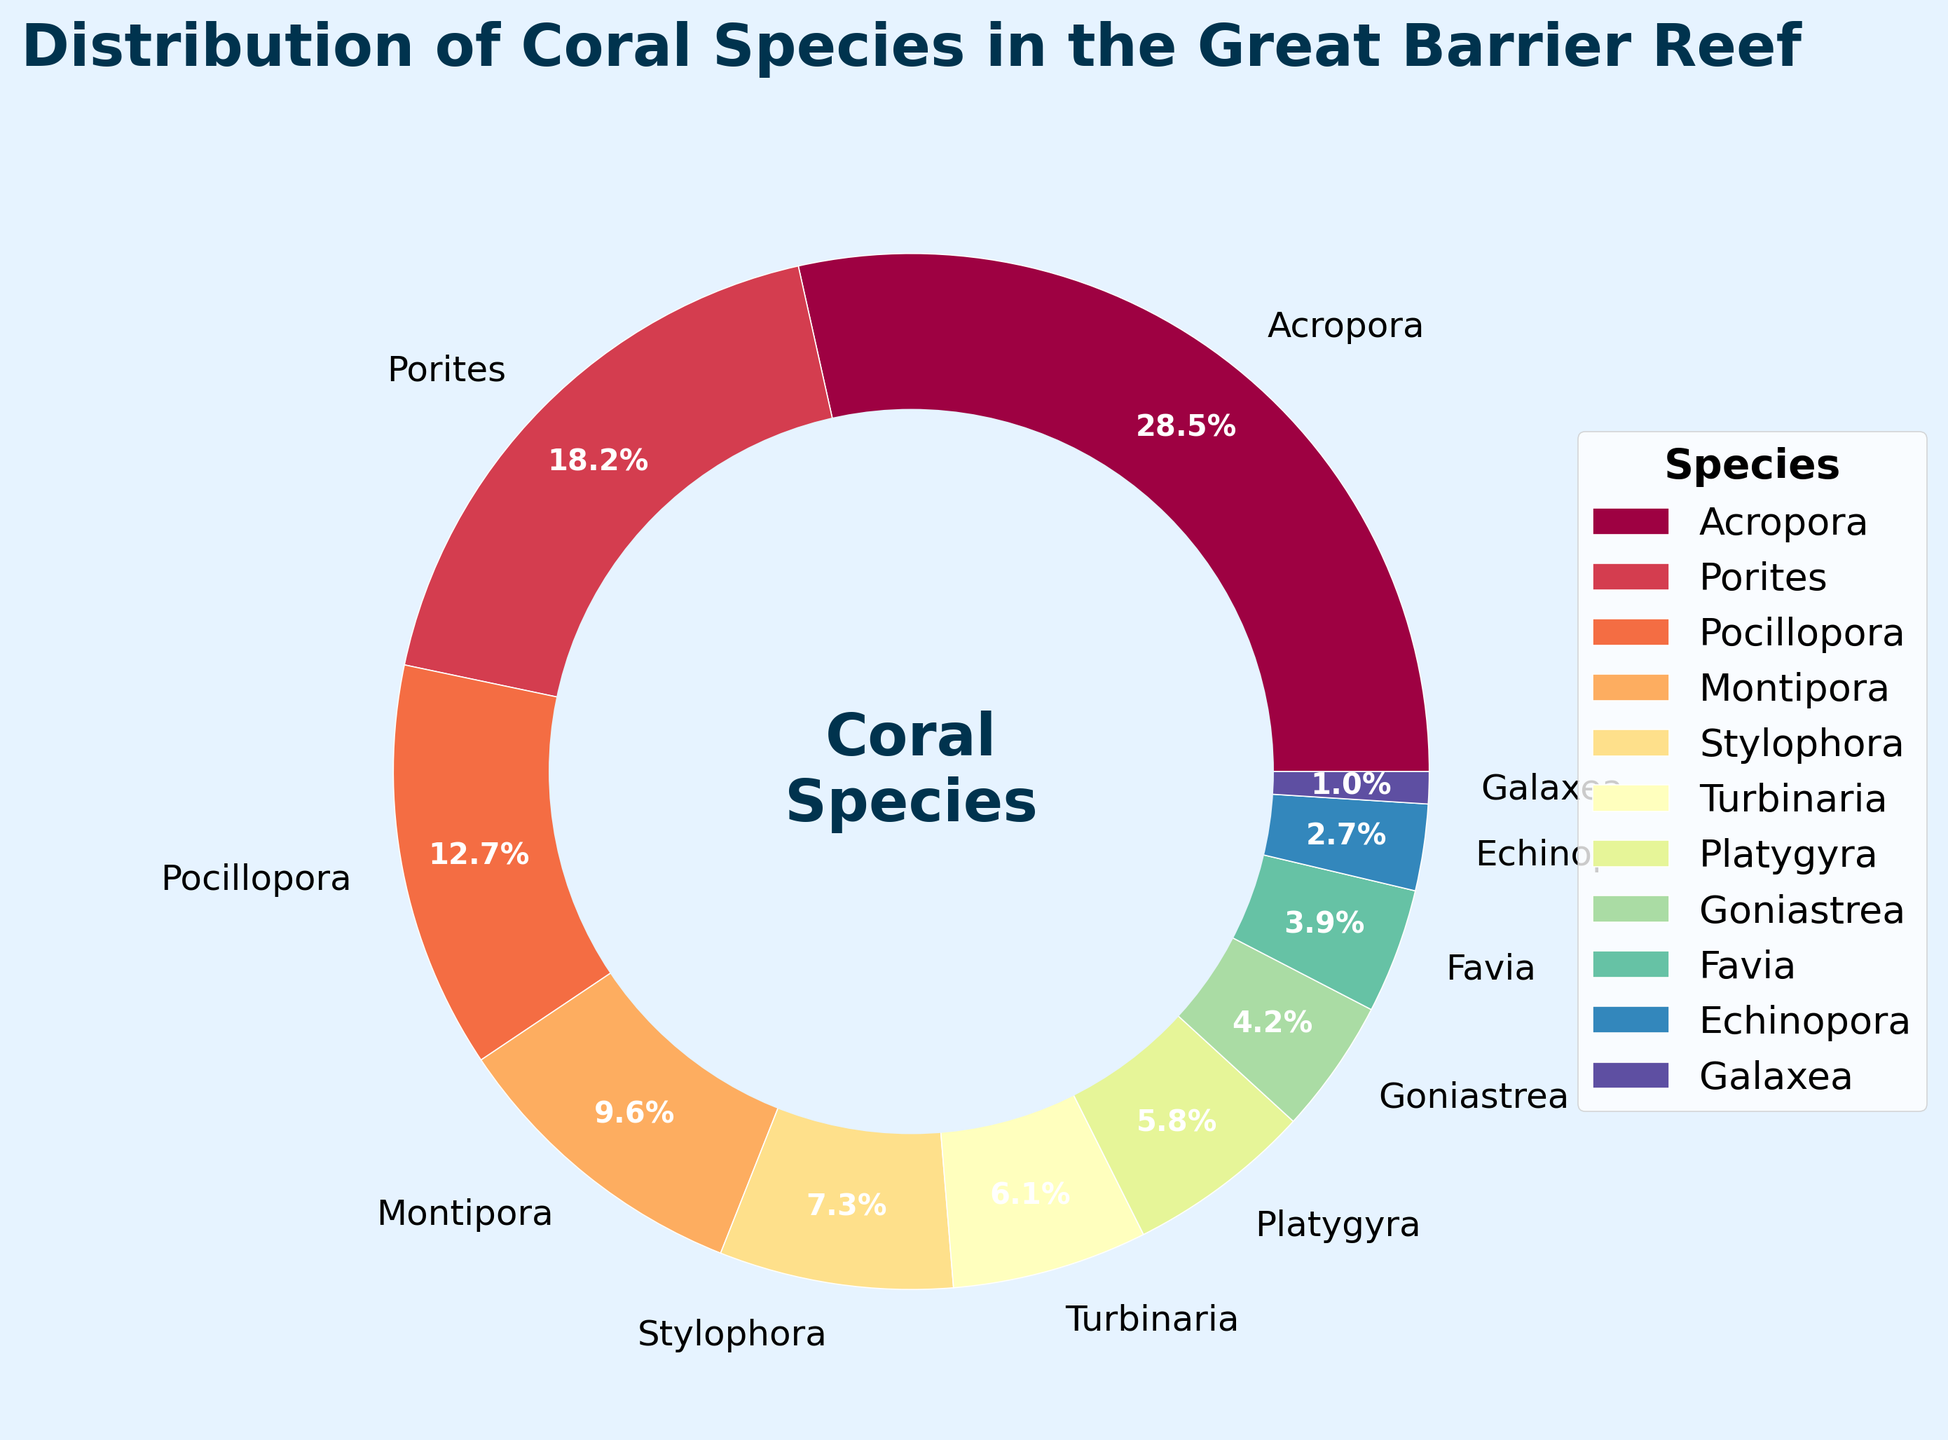What is the total percentage of the three most common coral species? The three most common coral species are Acropora (28.5%), Porites (18.2%), and Pocillopora (12.7%). Adding these percentages together gives us 28.5 + 18.2 + 12.7 = 59.4%.
Answer: 59.4% Which species has the smallest share of the ecosystem? The species with the smallest share of the ecosystem is Galaxea, which has a percentage of 1.0%.
Answer: Galaxea Is the percentage of Acropora greater than the combined percentage of Montipora and Stylophora? The percentage of Acropora is 28.5%. The combined percentage of Montipora (9.6%) and Stylophora (7.3%) is 9.6 + 7.3 = 16.9%. Since 28.5% is greater than 16.9%, Acropora's percentage is indeed greater.
Answer: Yes How much more percentage does Acropora have compared to Goniastrea? Acropora has 28.5%, while Goniastrea has 4.2%. The difference is 28.5 - 4.2 = 24.3%.
Answer: 24.3% If Montipora's and Turbinaria's percentages were combined, would they exceed Acropora's percentage? Montipora has 9.6%, and Turbinaria has 6.1%. Their combined percentage is 9.6 + 6.1 = 15.7%, which is less than Acropora's 28.5%.
Answer: No What is the combined percentage of Pocillopora, Stylophora, and Turbinaria? Pocillopora has 12.7%, Stylophora has 7.3%, and Turbinaria has 6.1%. Combined, their percentage is 12.7 + 7.3 + 6.1 = 26.1%.
Answer: 26.1% Which species contributes more to the ecosystem, Favia or Platygyra? Favia has 3.9%, and Platygyra has 5.8%. Since 5.8% is greater than 3.9%, Platygyra contributes more.
Answer: Platygyra By adding the percentages of Porites, Montipora, and Echinopora, does their combined share surpass 30%? Porites has 18.2%, Montipora has 9.6%, and Echinopora has 2.7%. Their combined percentage is 18.2 + 9.6 + 2.7 = 30.5%, which is greater than 30%.
Answer: Yes What is the difference in percentage between the species with the highest share and the species with the second-highest share? The highest share is Acropora with 28.5%, and the second-highest share is Porites with 18.2%. The difference is 28.5 - 18.2 = 10.3%.
Answer: 10.3% 